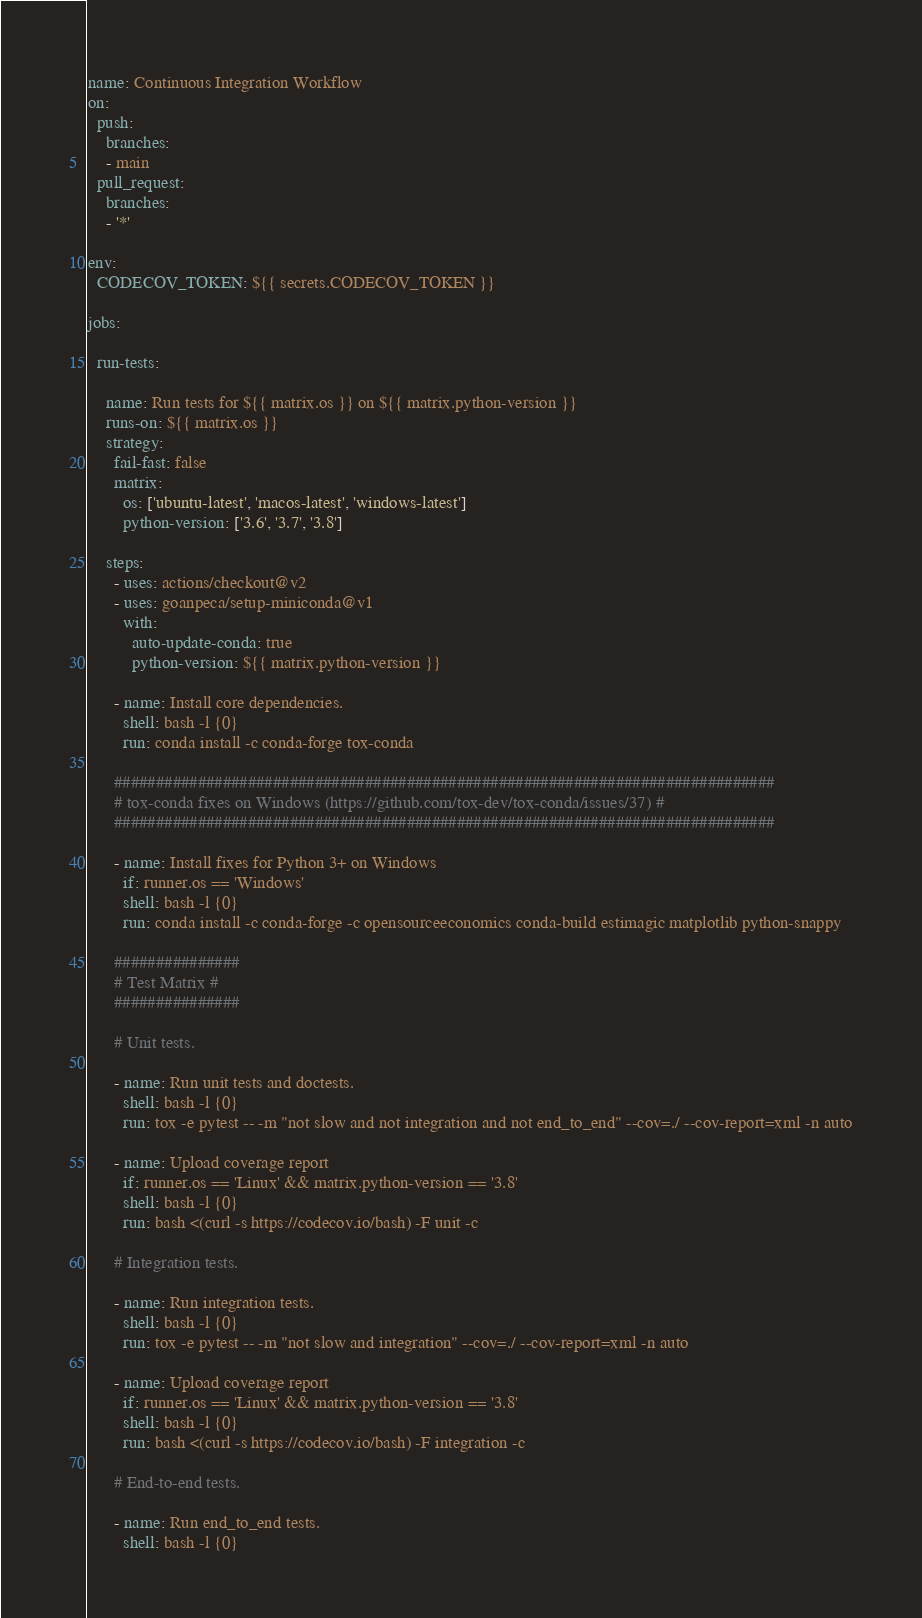Convert code to text. <code><loc_0><loc_0><loc_500><loc_500><_YAML_>name: Continuous Integration Workflow
on:
  push:
    branches:
    - main
  pull_request:
    branches:
    - '*'

env:
  CODECOV_TOKEN: ${{ secrets.CODECOV_TOKEN }}

jobs:

  run-tests:

    name: Run tests for ${{ matrix.os }} on ${{ matrix.python-version }}
    runs-on: ${{ matrix.os }}
    strategy:
      fail-fast: false
      matrix:
        os: ['ubuntu-latest', 'macos-latest', 'windows-latest']
        python-version: ['3.6', '3.7', '3.8']

    steps:
      - uses: actions/checkout@v2
      - uses: goanpeca/setup-miniconda@v1
        with:
          auto-update-conda: true
          python-version: ${{ matrix.python-version }}

      - name: Install core dependencies.
        shell: bash -l {0}
        run: conda install -c conda-forge tox-conda

      ###############################################################################
      # tox-conda fixes on Windows (https://github.com/tox-dev/tox-conda/issues/37) #
      ###############################################################################

      - name: Install fixes for Python 3+ on Windows
        if: runner.os == 'Windows'
        shell: bash -l {0}
        run: conda install -c conda-forge -c opensourceeconomics conda-build estimagic matplotlib python-snappy

      ###############
      # Test Matrix #
      ###############

      # Unit tests.

      - name: Run unit tests and doctests.
        shell: bash -l {0}
        run: tox -e pytest -- -m "not slow and not integration and not end_to_end" --cov=./ --cov-report=xml -n auto

      - name: Upload coverage report
        if: runner.os == 'Linux' && matrix.python-version == '3.8'
        shell: bash -l {0}
        run: bash <(curl -s https://codecov.io/bash) -F unit -c

      # Integration tests.

      - name: Run integration tests.
        shell: bash -l {0}
        run: tox -e pytest -- -m "not slow and integration" --cov=./ --cov-report=xml -n auto

      - name: Upload coverage report
        if: runner.os == 'Linux' && matrix.python-version == '3.8'
        shell: bash -l {0}
        run: bash <(curl -s https://codecov.io/bash) -F integration -c

      # End-to-end tests.

      - name: Run end_to_end tests.
        shell: bash -l {0}</code> 